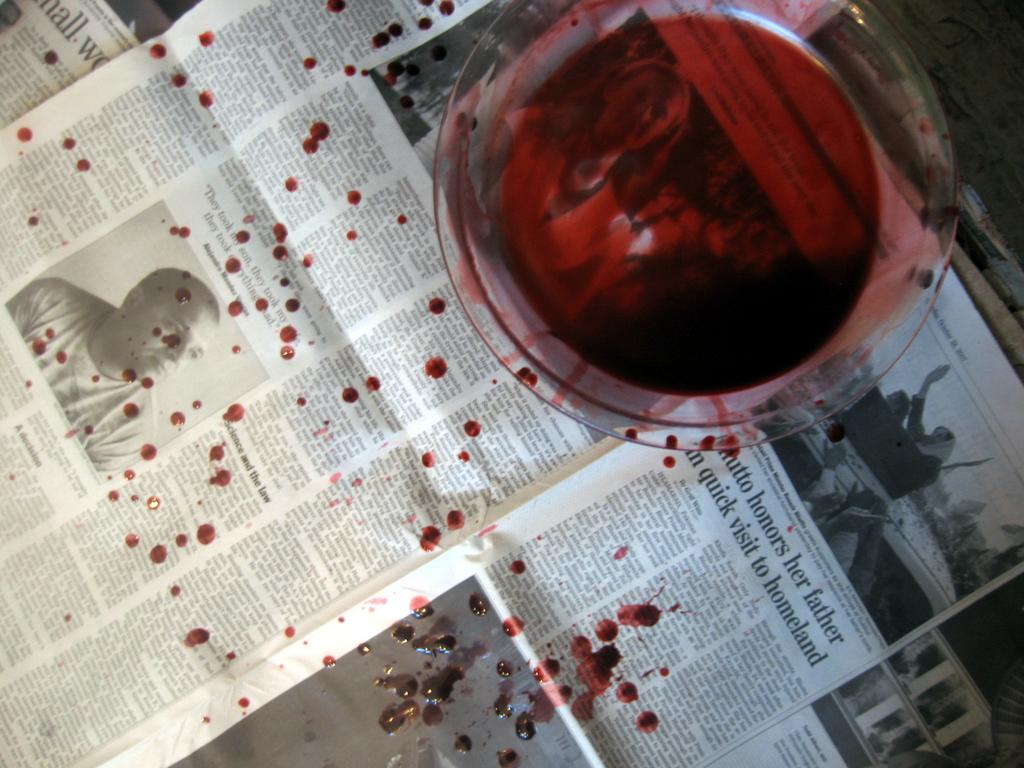Provide a one-sentence caption for the provided image. A glass of red wine has spilled on a paper with an article about someone honouring their father. 